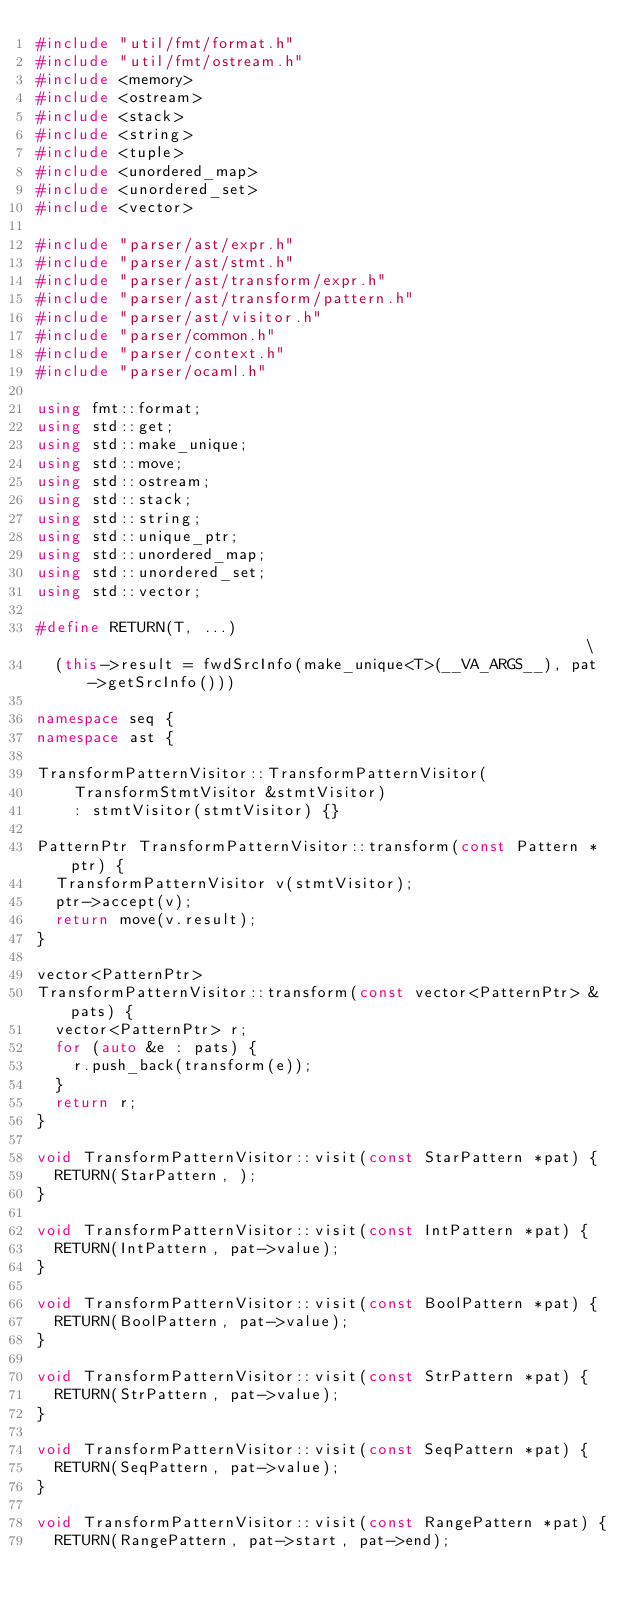Convert code to text. <code><loc_0><loc_0><loc_500><loc_500><_C++_>#include "util/fmt/format.h"
#include "util/fmt/ostream.h"
#include <memory>
#include <ostream>
#include <stack>
#include <string>
#include <tuple>
#include <unordered_map>
#include <unordered_set>
#include <vector>

#include "parser/ast/expr.h"
#include "parser/ast/stmt.h"
#include "parser/ast/transform/expr.h"
#include "parser/ast/transform/pattern.h"
#include "parser/ast/visitor.h"
#include "parser/common.h"
#include "parser/context.h"
#include "parser/ocaml.h"

using fmt::format;
using std::get;
using std::make_unique;
using std::move;
using std::ostream;
using std::stack;
using std::string;
using std::unique_ptr;
using std::unordered_map;
using std::unordered_set;
using std::vector;

#define RETURN(T, ...)                                                         \
  (this->result = fwdSrcInfo(make_unique<T>(__VA_ARGS__), pat->getSrcInfo()))

namespace seq {
namespace ast {

TransformPatternVisitor::TransformPatternVisitor(
    TransformStmtVisitor &stmtVisitor)
    : stmtVisitor(stmtVisitor) {}

PatternPtr TransformPatternVisitor::transform(const Pattern *ptr) {
  TransformPatternVisitor v(stmtVisitor);
  ptr->accept(v);
  return move(v.result);
}

vector<PatternPtr>
TransformPatternVisitor::transform(const vector<PatternPtr> &pats) {
  vector<PatternPtr> r;
  for (auto &e : pats) {
    r.push_back(transform(e));
  }
  return r;
}

void TransformPatternVisitor::visit(const StarPattern *pat) {
  RETURN(StarPattern, );
}

void TransformPatternVisitor::visit(const IntPattern *pat) {
  RETURN(IntPattern, pat->value);
}

void TransformPatternVisitor::visit(const BoolPattern *pat) {
  RETURN(BoolPattern, pat->value);
}

void TransformPatternVisitor::visit(const StrPattern *pat) {
  RETURN(StrPattern, pat->value);
}

void TransformPatternVisitor::visit(const SeqPattern *pat) {
  RETURN(SeqPattern, pat->value);
}

void TransformPatternVisitor::visit(const RangePattern *pat) {
  RETURN(RangePattern, pat->start, pat->end);</code> 